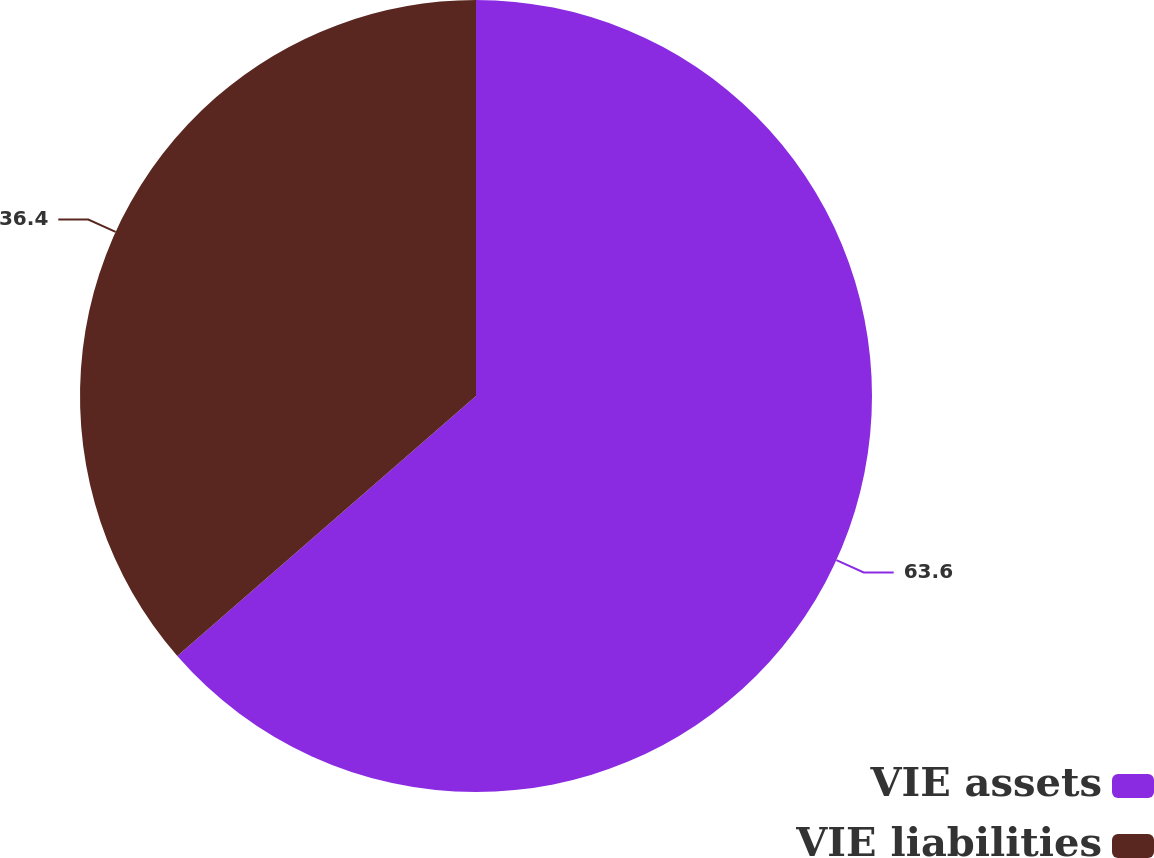Convert chart. <chart><loc_0><loc_0><loc_500><loc_500><pie_chart><fcel>VIE assets<fcel>VIE liabilities<nl><fcel>63.6%<fcel>36.4%<nl></chart> 